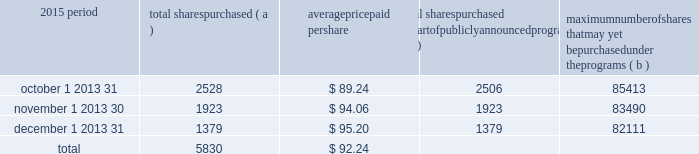We include here by reference additional information relating to pnc common stock under the common stock prices/ dividends declared section in the statistical information ( unaudited ) section of item 8 of this report .
We include here by reference the information regarding our compensation plans under which pnc equity securities are authorized for issuance as of december 31 , 2015 in the table ( with introductory paragraph and notes ) that appears under the caption 201capproval of 2016 incentive award plan 2013 item 3 201d in our proxy statement to be filed for the 2016 annual meeting of shareholders and is incorporated by reference herein and in item 12 of this report .
Our stock transfer agent and registrar is : computershare trust company , n.a .
250 royall street canton , ma 02021 800-982-7652 registered shareholders may contact the above phone number regarding dividends and other shareholder services .
We include here by reference the information that appears under the common stock performance graph caption at the end of this item 5 .
( a ) ( 2 ) none .
( b ) not applicable .
( c ) details of our repurchases of pnc common stock during the fourth quarter of 2015 are included in the table : in thousands , except per share data 2015 period total shares purchased ( a ) average paid per total shares purchased as part of publicly announced programs ( b ) maximum number of shares that may yet be purchased under the programs ( b ) .
( a ) includes pnc common stock purchased in connection with our various employee benefit plans generally related to forfeitures of unvested restricted stock awards and shares used to cover employee payroll tax withholding requirements .
Note 12 employee benefit plans and note 13 stock based compensation plans in the notes to consolidated financial statements in item 8 of this report include additional information regarding our employee benefit and equity compensation plans that use pnc common stock .
( b ) on march 11 , 2015 , we announced that our board of directors had approved the establishment of a new stock repurchase program authorization in the amount of 100 million shares of pnc common stock , effective april 1 , 2015 .
Repurchases are made in open market or privately negotiated transactions and the timing and exact amount of common stock repurchases will depend on a number of factors including , among others , market and general economic conditions , economic capital and regulatory capital considerations , alternative uses of capital , the potential impact on our credit ratings , and contractual and regulatory limitations , including the results of the supervisory assessment of capital adequacy and capital planning processes undertaken by the federal reserve as part of the ccar process .
Our 2015 capital plan , submitted as part of the ccar process and accepted by the federal reserve , included share repurchase programs of up to $ 2.875 billion for the five quarter period beginning with the second quarter of 2015 .
This amount does not include share repurchases in connection with various employee benefit plans referenced in note ( a ) .
In the fourth quarter of 2015 , in accordance with pnc 2019s 2015 capital plan and under the share repurchase authorization in effect during that period , we repurchased 5.8 million shares of common stock on the open market , with an average price of $ 92.26 per share and an aggregate repurchase price of $ .5 billion .
30 the pnc financial services group , inc .
2013 form 10-k .
For the fourth quarter of 2015 , what percentage of total shares was repurchase in the december 1 2013 31 period? 
Computations: (1379 / 5830)
Answer: 0.23654. 